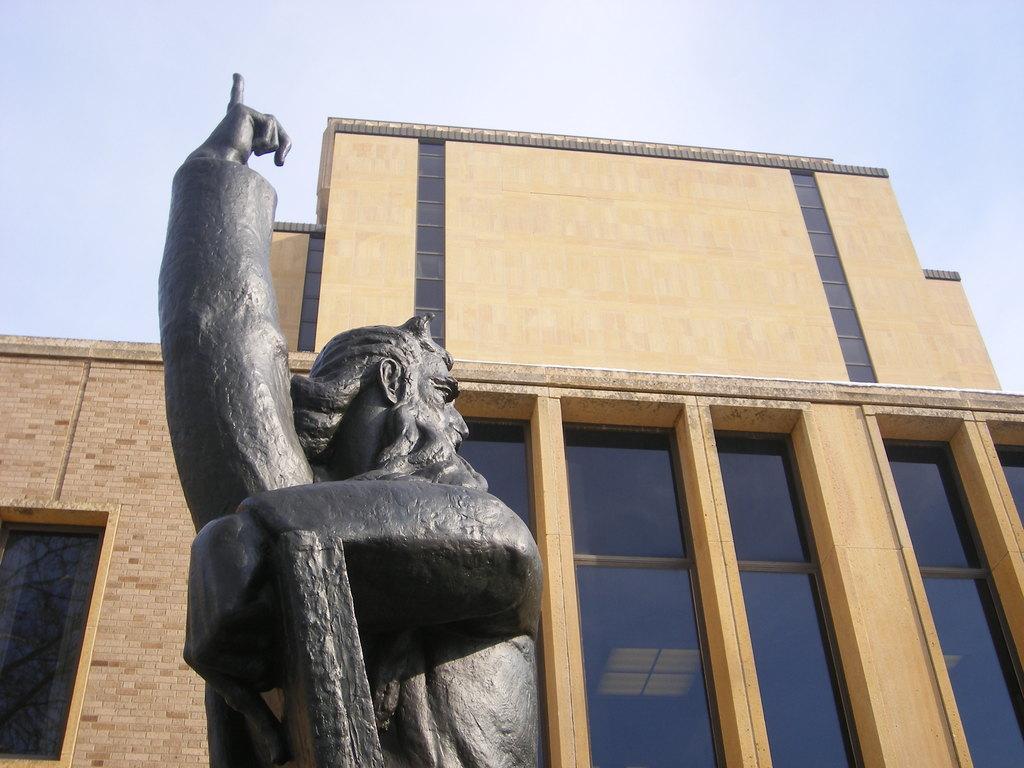Can you describe this image briefly? In the foreground of the picture there is statue. In the center of the picture there is a building with glass windows and brick wall. Sky is cloudy. 